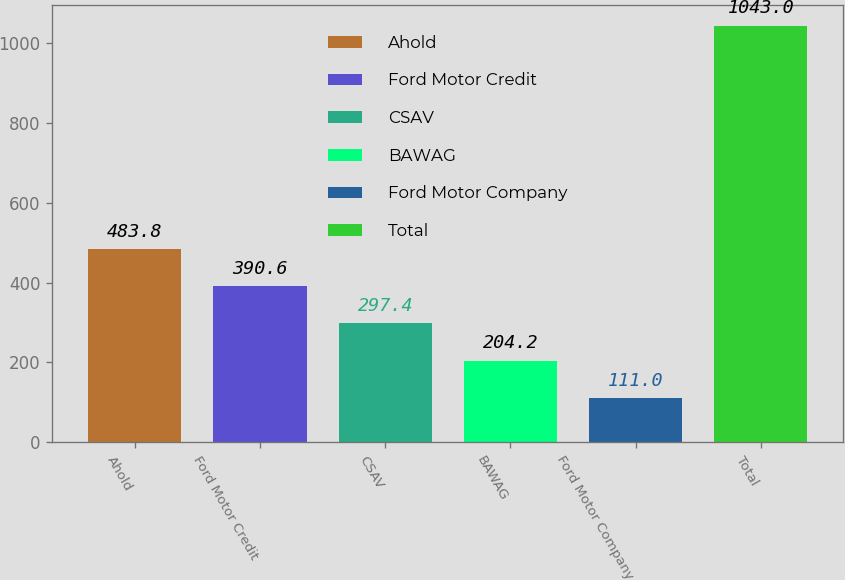Convert chart to OTSL. <chart><loc_0><loc_0><loc_500><loc_500><bar_chart><fcel>Ahold<fcel>Ford Motor Credit<fcel>CSAV<fcel>BAWAG<fcel>Ford Motor Company<fcel>Total<nl><fcel>483.8<fcel>390.6<fcel>297.4<fcel>204.2<fcel>111<fcel>1043<nl></chart> 